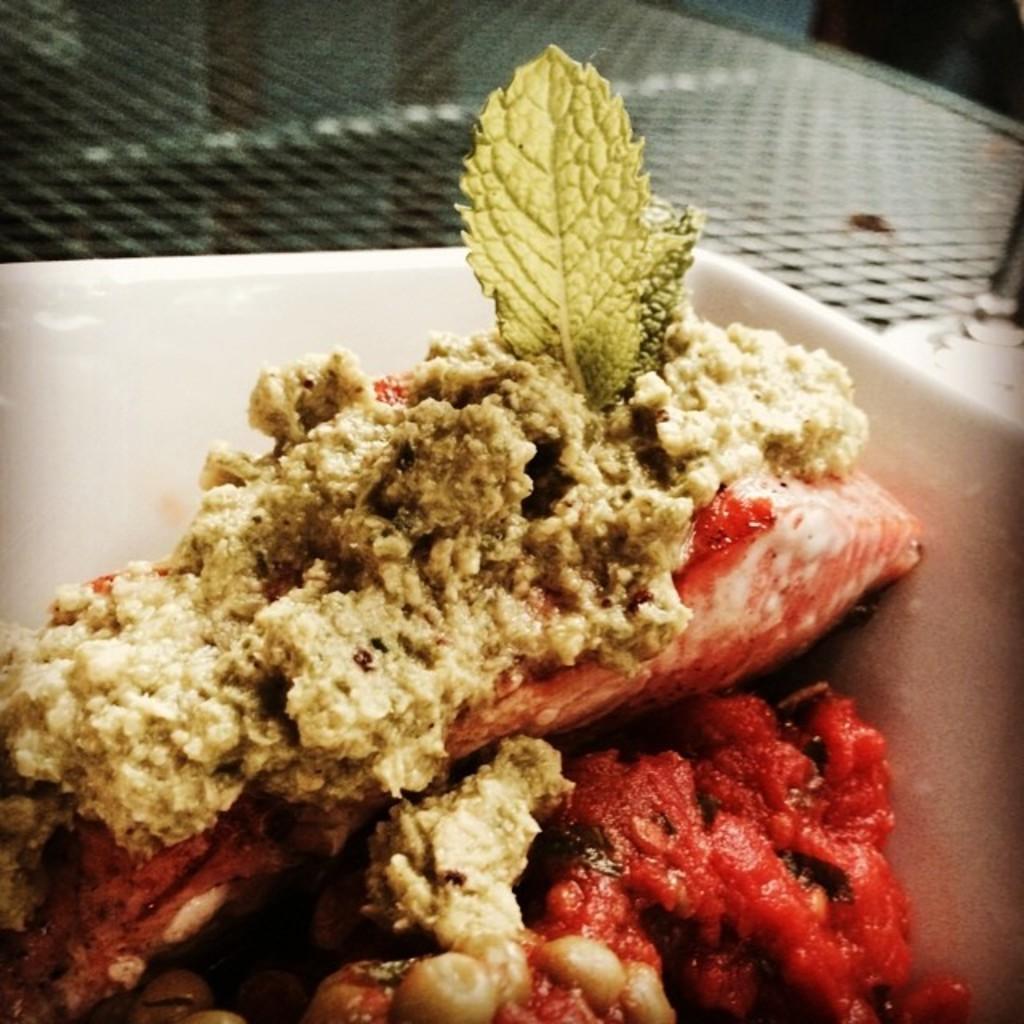Can you describe this image briefly? In this image I can see a white colour plate and in it I can see different types of food. 